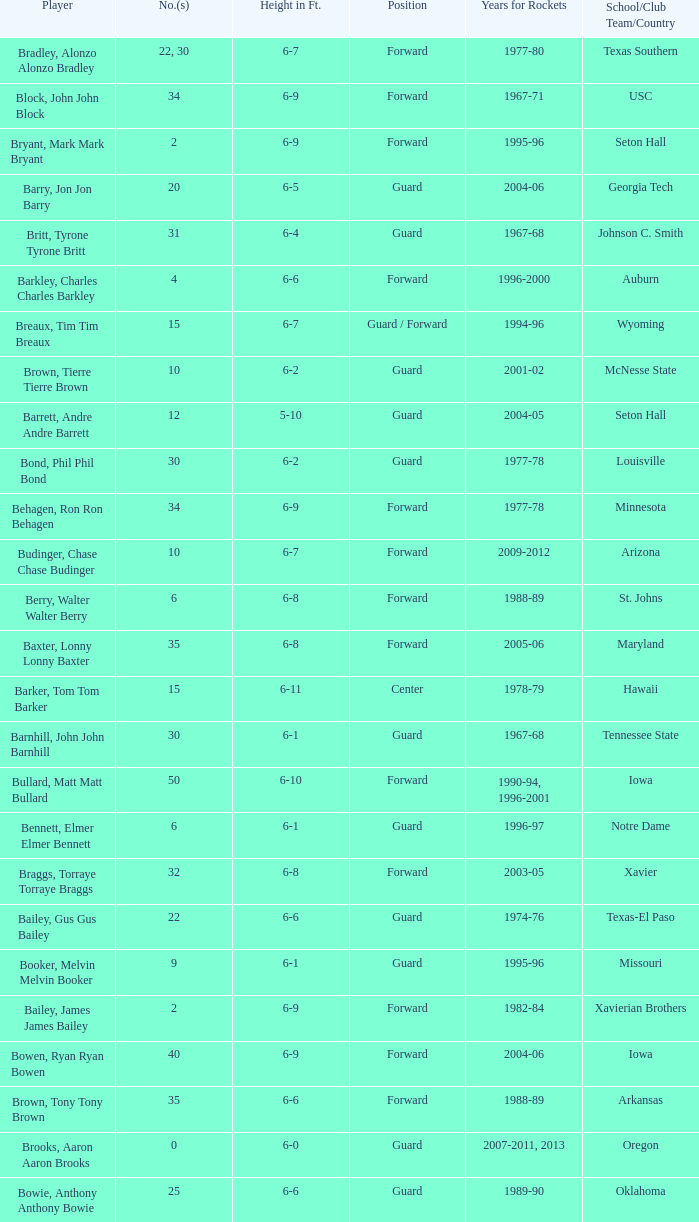Parse the table in full. {'header': ['Player', 'No.(s)', 'Height in Ft.', 'Position', 'Years for Rockets', 'School/Club Team/Country'], 'rows': [['Bradley, Alonzo Alonzo Bradley', '22, 30', '6-7', 'Forward', '1977-80', 'Texas Southern'], ['Block, John John Block', '34', '6-9', 'Forward', '1967-71', 'USC'], ['Bryant, Mark Mark Bryant', '2', '6-9', 'Forward', '1995-96', 'Seton Hall'], ['Barry, Jon Jon Barry', '20', '6-5', 'Guard', '2004-06', 'Georgia Tech'], ['Britt, Tyrone Tyrone Britt', '31', '6-4', 'Guard', '1967-68', 'Johnson C. Smith'], ['Barkley, Charles Charles Barkley', '4', '6-6', 'Forward', '1996-2000', 'Auburn'], ['Breaux, Tim Tim Breaux', '15', '6-7', 'Guard / Forward', '1994-96', 'Wyoming'], ['Brown, Tierre Tierre Brown', '10', '6-2', 'Guard', '2001-02', 'McNesse State'], ['Barrett, Andre Andre Barrett', '12', '5-10', 'Guard', '2004-05', 'Seton Hall'], ['Bond, Phil Phil Bond', '30', '6-2', 'Guard', '1977-78', 'Louisville'], ['Behagen, Ron Ron Behagen', '34', '6-9', 'Forward', '1977-78', 'Minnesota'], ['Budinger, Chase Chase Budinger', '10', '6-7', 'Forward', '2009-2012', 'Arizona'], ['Berry, Walter Walter Berry', '6', '6-8', 'Forward', '1988-89', 'St. Johns'], ['Baxter, Lonny Lonny Baxter', '35', '6-8', 'Forward', '2005-06', 'Maryland'], ['Barker, Tom Tom Barker', '15', '6-11', 'Center', '1978-79', 'Hawaii'], ['Barnhill, John John Barnhill', '30', '6-1', 'Guard', '1967-68', 'Tennessee State'], ['Bullard, Matt Matt Bullard', '50', '6-10', 'Forward', '1990-94, 1996-2001', 'Iowa'], ['Bennett, Elmer Elmer Bennett', '6', '6-1', 'Guard', '1996-97', 'Notre Dame'], ['Braggs, Torraye Torraye Braggs', '32', '6-8', 'Forward', '2003-05', 'Xavier'], ['Bailey, Gus Gus Bailey', '22', '6-6', 'Guard', '1974-76', 'Texas-El Paso'], ['Booker, Melvin Melvin Booker', '9', '6-1', 'Guard', '1995-96', 'Missouri'], ['Bailey, James James Bailey', '2', '6-9', 'Forward', '1982-84', 'Xavierian Brothers'], ['Bowen, Ryan Ryan Bowen', '40', '6-9', 'Forward', '2004-06', 'Iowa'], ['Brown, Tony Tony Brown', '35', '6-6', 'Forward', '1988-89', 'Arkansas'], ['Brooks, Aaron Aaron Brooks', '0', '6-0', 'Guard', '2007-2011, 2013', 'Oregon'], ['Bowie, Anthony Anthony Bowie', '25', '6-6', 'Guard', '1989-90', 'Oklahoma'], ['Barry, Brent Brent Barry', '17', '6-7', 'Guard', '2008-09', 'Oregon State'], ['Bryant, Joe Joe Bryant', '22', '6-9', 'Forward / Guard', '1982-83', 'LaSalle'], ['Barry, Rick Rick Barry', '2', '6-8', 'Forward', '1978-80', 'Miami'], ['Bogans, Keith Keith Bogans', '10', '6-5', 'Guard / Forward', '2005-06', 'Kentucky'], ['Barnett, Jim Jim Barnett', '33', '6-4', 'Guard', '1967-70', 'Oregon'], ['Baker, Vin Vin Baker', '42', '6-11', 'Forward', '2004-05', 'Hartford'], ['Brunson, Rick Rick Brunson', '9', '6-4', 'Guard', '2005-06', 'Temple'], ['Battier, Shane Shane Battier', '31', '6-8', 'Forward', '2006-2011', 'Duke'], ['Brooks, Scott Scott Brooks', '1', '5-11', 'Guard', '1992-95', 'UC-Irvine'], ['Barnes, Harry Harry Barnes', '30', '6-3', 'Forward', '1968-69', 'Northeastern'], ['Brown, Chucky Chucky Brown', '52', '6-8', 'Forward', '1994-96', 'North Carolina']]} What years did the player from LaSalle play for the Rockets? 1982-83. 